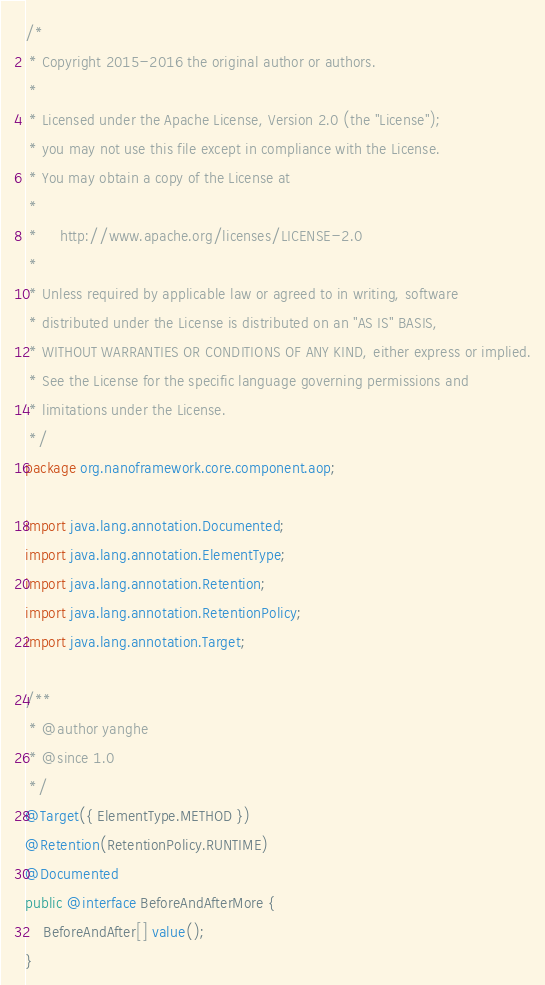<code> <loc_0><loc_0><loc_500><loc_500><_Java_>/*
 * Copyright 2015-2016 the original author or authors.
 *
 * Licensed under the Apache License, Version 2.0 (the "License");
 * you may not use this file except in compliance with the License.
 * You may obtain a copy of the License at
 *
 *     http://www.apache.org/licenses/LICENSE-2.0
 *
 * Unless required by applicable law or agreed to in writing, software
 * distributed under the License is distributed on an "AS IS" BASIS,
 * WITHOUT WARRANTIES OR CONDITIONS OF ANY KIND, either express or implied.
 * See the License for the specific language governing permissions and
 * limitations under the License.
 */
package org.nanoframework.core.component.aop;

import java.lang.annotation.Documented;
import java.lang.annotation.ElementType;
import java.lang.annotation.Retention;
import java.lang.annotation.RetentionPolicy;
import java.lang.annotation.Target;

/**
 * @author yanghe
 * @since 1.0
 */
@Target({ ElementType.METHOD })
@Retention(RetentionPolicy.RUNTIME)
@Documented
public @interface BeforeAndAfterMore {
    BeforeAndAfter[] value();
}
</code> 